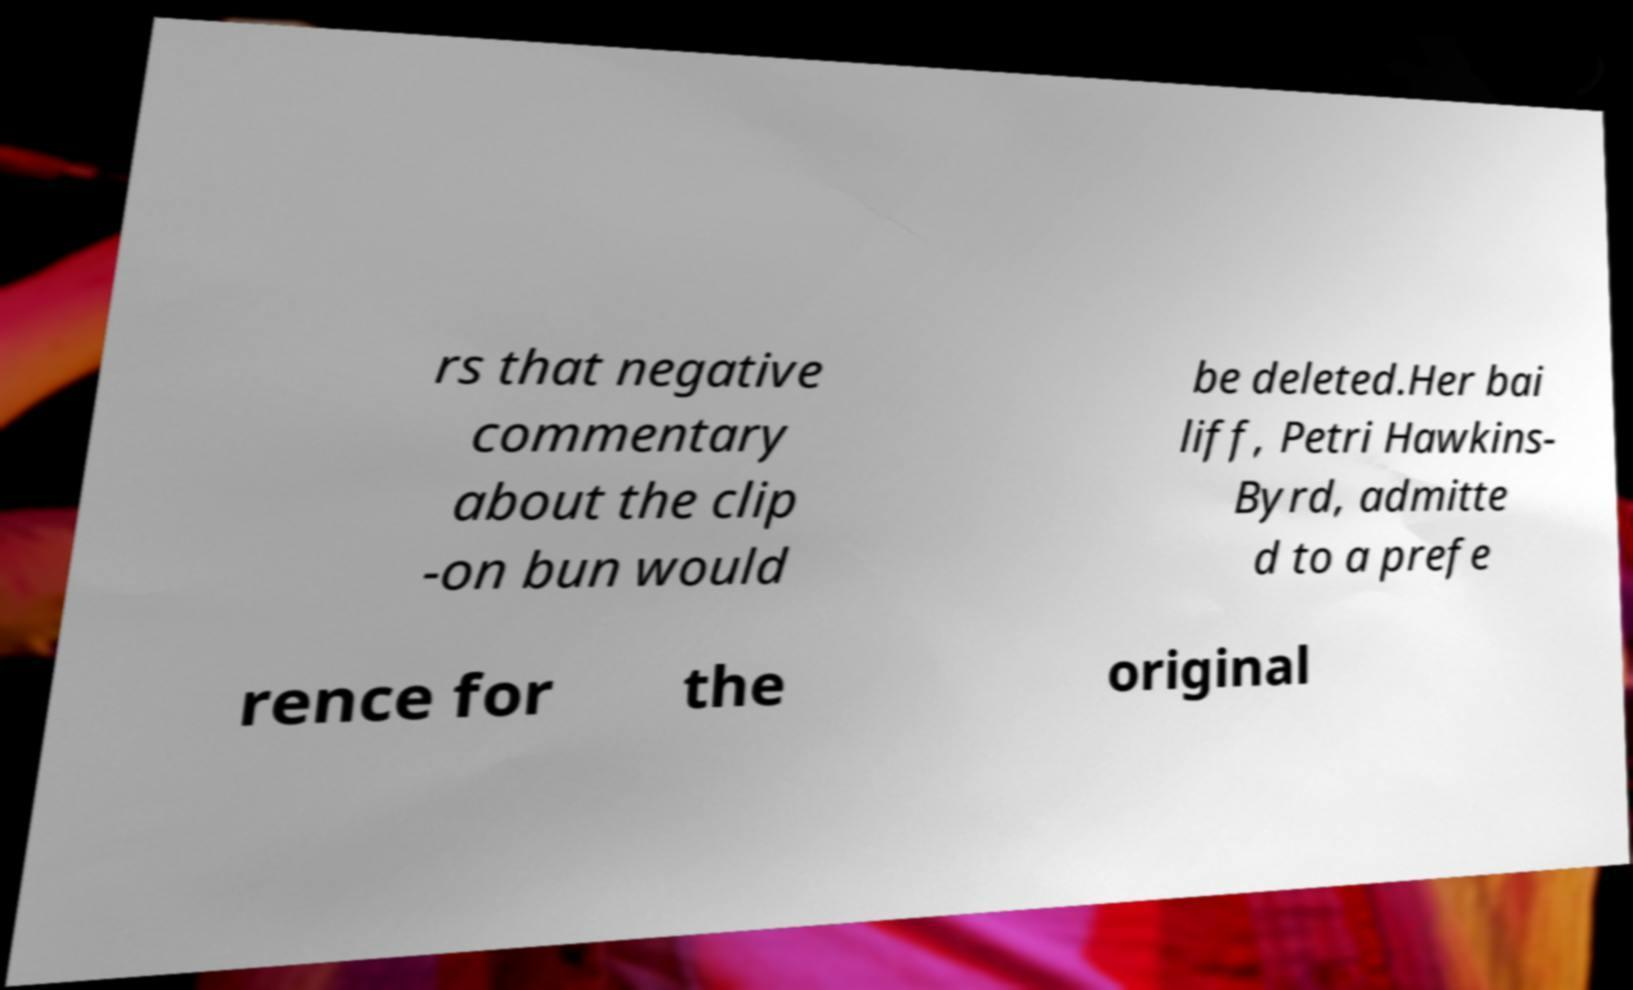Could you extract and type out the text from this image? rs that negative commentary about the clip -on bun would be deleted.Her bai liff, Petri Hawkins- Byrd, admitte d to a prefe rence for the original 